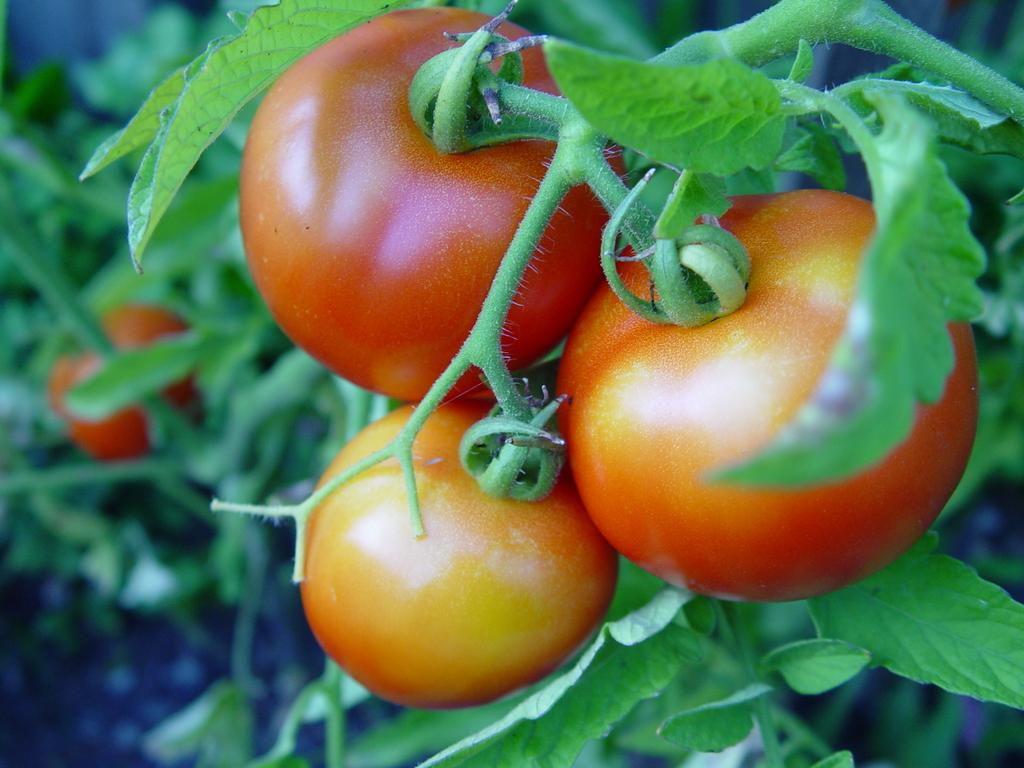What type of fruit can be seen in the image? There are tomatoes in the image. Are there any additional features visible on the tomatoes? Yes, the tomatoes have leaves. What type of flower is growing next to the tomatoes in the image? There is no flower present in the image; it only features tomatoes with leaves. 